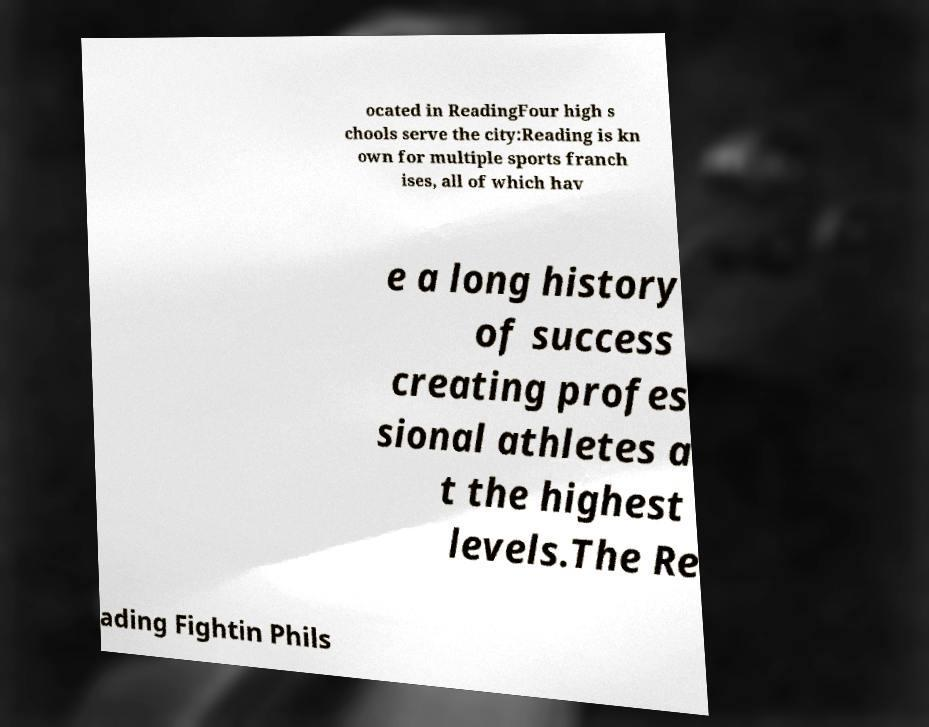For documentation purposes, I need the text within this image transcribed. Could you provide that? ocated in ReadingFour high s chools serve the city:Reading is kn own for multiple sports franch ises, all of which hav e a long history of success creating profes sional athletes a t the highest levels.The Re ading Fightin Phils 